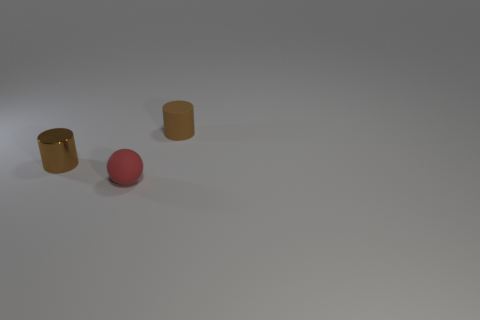Add 3 tiny brown things. How many objects exist? 6 Subtract all cylinders. How many objects are left? 1 Subtract 1 red balls. How many objects are left? 2 Subtract all tiny purple blocks. Subtract all brown things. How many objects are left? 1 Add 1 small cylinders. How many small cylinders are left? 3 Add 3 tiny red balls. How many tiny red balls exist? 4 